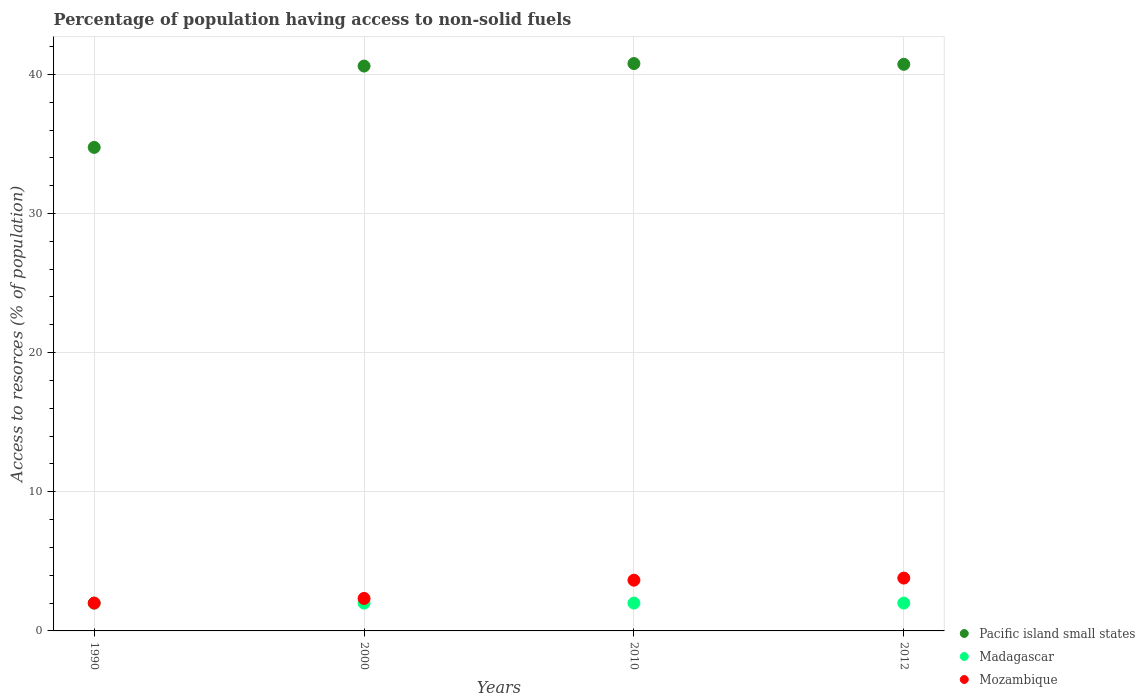How many different coloured dotlines are there?
Ensure brevity in your answer.  3. What is the percentage of population having access to non-solid fuels in Madagascar in 1990?
Give a very brief answer. 2. Across all years, what is the maximum percentage of population having access to non-solid fuels in Pacific island small states?
Ensure brevity in your answer.  40.78. Across all years, what is the minimum percentage of population having access to non-solid fuels in Mozambique?
Provide a short and direct response. 2. In which year was the percentage of population having access to non-solid fuels in Madagascar minimum?
Ensure brevity in your answer.  1990. What is the total percentage of population having access to non-solid fuels in Madagascar in the graph?
Offer a very short reply. 8. What is the difference between the percentage of population having access to non-solid fuels in Mozambique in 1990 and that in 2012?
Provide a succinct answer. -1.8. What is the difference between the percentage of population having access to non-solid fuels in Mozambique in 2012 and the percentage of population having access to non-solid fuels in Pacific island small states in 2010?
Make the answer very short. -36.98. What is the average percentage of population having access to non-solid fuels in Madagascar per year?
Your answer should be compact. 2. In the year 2000, what is the difference between the percentage of population having access to non-solid fuels in Pacific island small states and percentage of population having access to non-solid fuels in Mozambique?
Offer a terse response. 38.26. What is the ratio of the percentage of population having access to non-solid fuels in Madagascar in 2000 to that in 2012?
Ensure brevity in your answer.  1. Is the percentage of population having access to non-solid fuels in Madagascar in 1990 less than that in 2012?
Your answer should be compact. No. What is the difference between the highest and the second highest percentage of population having access to non-solid fuels in Pacific island small states?
Make the answer very short. 0.06. What is the difference between the highest and the lowest percentage of population having access to non-solid fuels in Pacific island small states?
Provide a succinct answer. 6.03. In how many years, is the percentage of population having access to non-solid fuels in Madagascar greater than the average percentage of population having access to non-solid fuels in Madagascar taken over all years?
Offer a very short reply. 0. Is it the case that in every year, the sum of the percentage of population having access to non-solid fuels in Mozambique and percentage of population having access to non-solid fuels in Madagascar  is greater than the percentage of population having access to non-solid fuels in Pacific island small states?
Give a very brief answer. No. How many dotlines are there?
Your response must be concise. 3. How many years are there in the graph?
Provide a short and direct response. 4. Are the values on the major ticks of Y-axis written in scientific E-notation?
Your answer should be very brief. No. Does the graph contain any zero values?
Keep it short and to the point. No. Where does the legend appear in the graph?
Ensure brevity in your answer.  Bottom right. How are the legend labels stacked?
Make the answer very short. Vertical. What is the title of the graph?
Ensure brevity in your answer.  Percentage of population having access to non-solid fuels. What is the label or title of the Y-axis?
Your answer should be very brief. Access to resorces (% of population). What is the Access to resorces (% of population) in Pacific island small states in 1990?
Your answer should be compact. 34.75. What is the Access to resorces (% of population) of Madagascar in 1990?
Ensure brevity in your answer.  2. What is the Access to resorces (% of population) of Mozambique in 1990?
Offer a terse response. 2. What is the Access to resorces (% of population) of Pacific island small states in 2000?
Your answer should be very brief. 40.6. What is the Access to resorces (% of population) of Madagascar in 2000?
Provide a succinct answer. 2. What is the Access to resorces (% of population) in Mozambique in 2000?
Give a very brief answer. 2.34. What is the Access to resorces (% of population) in Pacific island small states in 2010?
Give a very brief answer. 40.78. What is the Access to resorces (% of population) in Madagascar in 2010?
Your answer should be compact. 2. What is the Access to resorces (% of population) in Mozambique in 2010?
Your response must be concise. 3.65. What is the Access to resorces (% of population) of Pacific island small states in 2012?
Provide a short and direct response. 40.72. What is the Access to resorces (% of population) of Madagascar in 2012?
Offer a terse response. 2. What is the Access to resorces (% of population) of Mozambique in 2012?
Your answer should be very brief. 3.8. Across all years, what is the maximum Access to resorces (% of population) of Pacific island small states?
Offer a terse response. 40.78. Across all years, what is the maximum Access to resorces (% of population) in Madagascar?
Keep it short and to the point. 2. Across all years, what is the maximum Access to resorces (% of population) in Mozambique?
Ensure brevity in your answer.  3.8. Across all years, what is the minimum Access to resorces (% of population) of Pacific island small states?
Provide a short and direct response. 34.75. Across all years, what is the minimum Access to resorces (% of population) of Madagascar?
Provide a succinct answer. 2. Across all years, what is the minimum Access to resorces (% of population) of Mozambique?
Your answer should be very brief. 2. What is the total Access to resorces (% of population) of Pacific island small states in the graph?
Make the answer very short. 156.84. What is the total Access to resorces (% of population) of Mozambique in the graph?
Offer a terse response. 11.78. What is the difference between the Access to resorces (% of population) of Pacific island small states in 1990 and that in 2000?
Your answer should be compact. -5.85. What is the difference between the Access to resorces (% of population) of Mozambique in 1990 and that in 2000?
Provide a succinct answer. -0.34. What is the difference between the Access to resorces (% of population) in Pacific island small states in 1990 and that in 2010?
Provide a succinct answer. -6.03. What is the difference between the Access to resorces (% of population) of Mozambique in 1990 and that in 2010?
Provide a short and direct response. -1.65. What is the difference between the Access to resorces (% of population) in Pacific island small states in 1990 and that in 2012?
Offer a terse response. -5.97. What is the difference between the Access to resorces (% of population) of Mozambique in 1990 and that in 2012?
Keep it short and to the point. -1.8. What is the difference between the Access to resorces (% of population) of Pacific island small states in 2000 and that in 2010?
Provide a succinct answer. -0.18. What is the difference between the Access to resorces (% of population) in Mozambique in 2000 and that in 2010?
Provide a short and direct response. -1.31. What is the difference between the Access to resorces (% of population) of Pacific island small states in 2000 and that in 2012?
Offer a very short reply. -0.12. What is the difference between the Access to resorces (% of population) of Madagascar in 2000 and that in 2012?
Keep it short and to the point. 0. What is the difference between the Access to resorces (% of population) in Mozambique in 2000 and that in 2012?
Offer a terse response. -1.46. What is the difference between the Access to resorces (% of population) of Pacific island small states in 2010 and that in 2012?
Offer a terse response. 0.06. What is the difference between the Access to resorces (% of population) of Mozambique in 2010 and that in 2012?
Give a very brief answer. -0.15. What is the difference between the Access to resorces (% of population) in Pacific island small states in 1990 and the Access to resorces (% of population) in Madagascar in 2000?
Your answer should be compact. 32.75. What is the difference between the Access to resorces (% of population) in Pacific island small states in 1990 and the Access to resorces (% of population) in Mozambique in 2000?
Keep it short and to the point. 32.41. What is the difference between the Access to resorces (% of population) in Madagascar in 1990 and the Access to resorces (% of population) in Mozambique in 2000?
Your answer should be compact. -0.34. What is the difference between the Access to resorces (% of population) in Pacific island small states in 1990 and the Access to resorces (% of population) in Madagascar in 2010?
Keep it short and to the point. 32.75. What is the difference between the Access to resorces (% of population) in Pacific island small states in 1990 and the Access to resorces (% of population) in Mozambique in 2010?
Offer a terse response. 31.1. What is the difference between the Access to resorces (% of population) in Madagascar in 1990 and the Access to resorces (% of population) in Mozambique in 2010?
Provide a succinct answer. -1.65. What is the difference between the Access to resorces (% of population) in Pacific island small states in 1990 and the Access to resorces (% of population) in Madagascar in 2012?
Keep it short and to the point. 32.75. What is the difference between the Access to resorces (% of population) of Pacific island small states in 1990 and the Access to resorces (% of population) of Mozambique in 2012?
Provide a short and direct response. 30.95. What is the difference between the Access to resorces (% of population) in Madagascar in 1990 and the Access to resorces (% of population) in Mozambique in 2012?
Ensure brevity in your answer.  -1.8. What is the difference between the Access to resorces (% of population) of Pacific island small states in 2000 and the Access to resorces (% of population) of Madagascar in 2010?
Give a very brief answer. 38.6. What is the difference between the Access to resorces (% of population) in Pacific island small states in 2000 and the Access to resorces (% of population) in Mozambique in 2010?
Your answer should be compact. 36.95. What is the difference between the Access to resorces (% of population) of Madagascar in 2000 and the Access to resorces (% of population) of Mozambique in 2010?
Provide a succinct answer. -1.65. What is the difference between the Access to resorces (% of population) of Pacific island small states in 2000 and the Access to resorces (% of population) of Madagascar in 2012?
Offer a terse response. 38.6. What is the difference between the Access to resorces (% of population) in Pacific island small states in 2000 and the Access to resorces (% of population) in Mozambique in 2012?
Your response must be concise. 36.8. What is the difference between the Access to resorces (% of population) of Madagascar in 2000 and the Access to resorces (% of population) of Mozambique in 2012?
Provide a succinct answer. -1.8. What is the difference between the Access to resorces (% of population) of Pacific island small states in 2010 and the Access to resorces (% of population) of Madagascar in 2012?
Ensure brevity in your answer.  38.78. What is the difference between the Access to resorces (% of population) of Pacific island small states in 2010 and the Access to resorces (% of population) of Mozambique in 2012?
Provide a succinct answer. 36.98. What is the difference between the Access to resorces (% of population) of Madagascar in 2010 and the Access to resorces (% of population) of Mozambique in 2012?
Provide a short and direct response. -1.8. What is the average Access to resorces (% of population) in Pacific island small states per year?
Ensure brevity in your answer.  39.21. What is the average Access to resorces (% of population) of Mozambique per year?
Keep it short and to the point. 2.94. In the year 1990, what is the difference between the Access to resorces (% of population) in Pacific island small states and Access to resorces (% of population) in Madagascar?
Provide a succinct answer. 32.75. In the year 1990, what is the difference between the Access to resorces (% of population) in Pacific island small states and Access to resorces (% of population) in Mozambique?
Offer a very short reply. 32.75. In the year 1990, what is the difference between the Access to resorces (% of population) of Madagascar and Access to resorces (% of population) of Mozambique?
Make the answer very short. 0. In the year 2000, what is the difference between the Access to resorces (% of population) of Pacific island small states and Access to resorces (% of population) of Madagascar?
Provide a short and direct response. 38.6. In the year 2000, what is the difference between the Access to resorces (% of population) in Pacific island small states and Access to resorces (% of population) in Mozambique?
Provide a short and direct response. 38.26. In the year 2000, what is the difference between the Access to resorces (% of population) in Madagascar and Access to resorces (% of population) in Mozambique?
Give a very brief answer. -0.34. In the year 2010, what is the difference between the Access to resorces (% of population) in Pacific island small states and Access to resorces (% of population) in Madagascar?
Keep it short and to the point. 38.78. In the year 2010, what is the difference between the Access to resorces (% of population) in Pacific island small states and Access to resorces (% of population) in Mozambique?
Offer a very short reply. 37.13. In the year 2010, what is the difference between the Access to resorces (% of population) of Madagascar and Access to resorces (% of population) of Mozambique?
Your response must be concise. -1.65. In the year 2012, what is the difference between the Access to resorces (% of population) of Pacific island small states and Access to resorces (% of population) of Madagascar?
Keep it short and to the point. 38.72. In the year 2012, what is the difference between the Access to resorces (% of population) in Pacific island small states and Access to resorces (% of population) in Mozambique?
Your answer should be compact. 36.92. In the year 2012, what is the difference between the Access to resorces (% of population) in Madagascar and Access to resorces (% of population) in Mozambique?
Provide a short and direct response. -1.8. What is the ratio of the Access to resorces (% of population) in Pacific island small states in 1990 to that in 2000?
Your answer should be very brief. 0.86. What is the ratio of the Access to resorces (% of population) of Mozambique in 1990 to that in 2000?
Your answer should be compact. 0.86. What is the ratio of the Access to resorces (% of population) of Pacific island small states in 1990 to that in 2010?
Offer a very short reply. 0.85. What is the ratio of the Access to resorces (% of population) in Mozambique in 1990 to that in 2010?
Offer a very short reply. 0.55. What is the ratio of the Access to resorces (% of population) of Pacific island small states in 1990 to that in 2012?
Give a very brief answer. 0.85. What is the ratio of the Access to resorces (% of population) of Mozambique in 1990 to that in 2012?
Provide a succinct answer. 0.53. What is the ratio of the Access to resorces (% of population) of Pacific island small states in 2000 to that in 2010?
Keep it short and to the point. 1. What is the ratio of the Access to resorces (% of population) in Mozambique in 2000 to that in 2010?
Your answer should be compact. 0.64. What is the ratio of the Access to resorces (% of population) of Madagascar in 2000 to that in 2012?
Your answer should be compact. 1. What is the ratio of the Access to resorces (% of population) in Mozambique in 2000 to that in 2012?
Keep it short and to the point. 0.61. What is the ratio of the Access to resorces (% of population) in Madagascar in 2010 to that in 2012?
Make the answer very short. 1. What is the ratio of the Access to resorces (% of population) of Mozambique in 2010 to that in 2012?
Make the answer very short. 0.96. What is the difference between the highest and the second highest Access to resorces (% of population) in Pacific island small states?
Provide a short and direct response. 0.06. What is the difference between the highest and the second highest Access to resorces (% of population) of Mozambique?
Your response must be concise. 0.15. What is the difference between the highest and the lowest Access to resorces (% of population) in Pacific island small states?
Offer a very short reply. 6.03. What is the difference between the highest and the lowest Access to resorces (% of population) of Mozambique?
Offer a terse response. 1.8. 